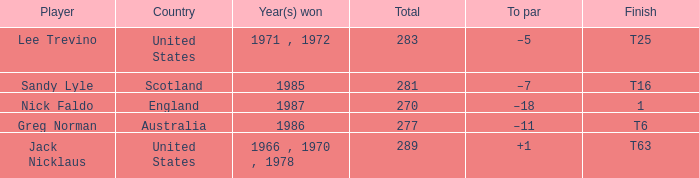What player has 289 as the total? Jack Nicklaus. 